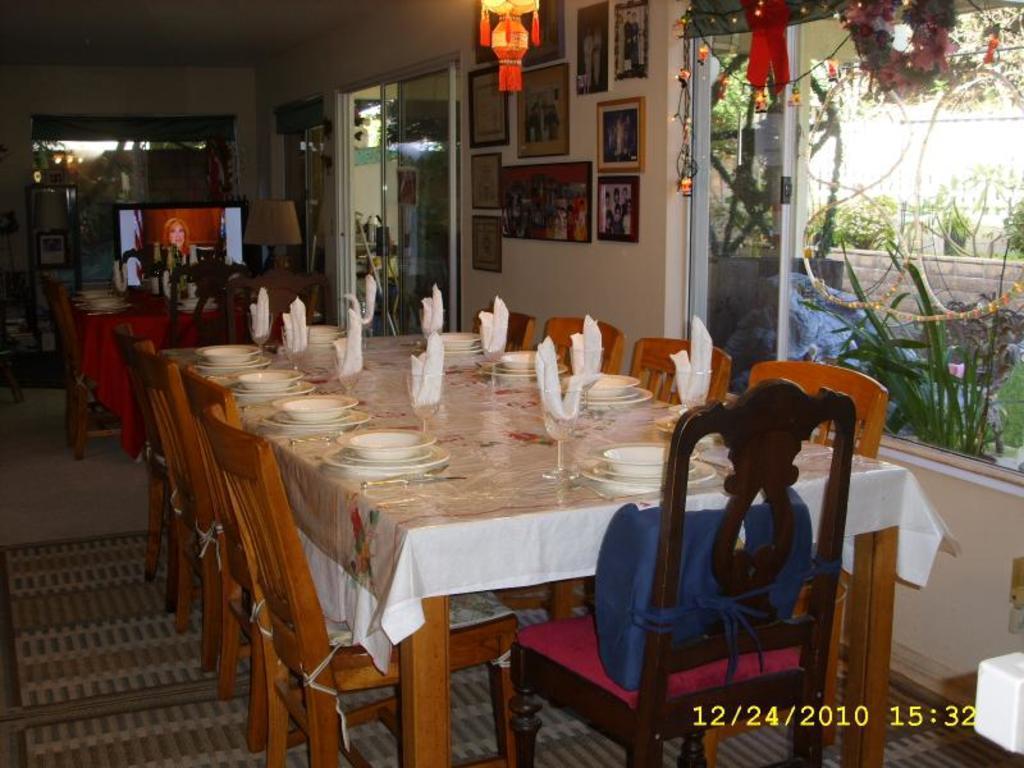Please provide a concise description of this image. In this image there are tables and chairs. We can see plates, bowls, glasses and napkins placed on the table. In the background there is a wall and we can see photo frames placed on the wall. There is a window and we can see a door. On the left there is a television and a lamp. At the bottom there is a floor mat and we can see plants through the window glass. There are decors. 